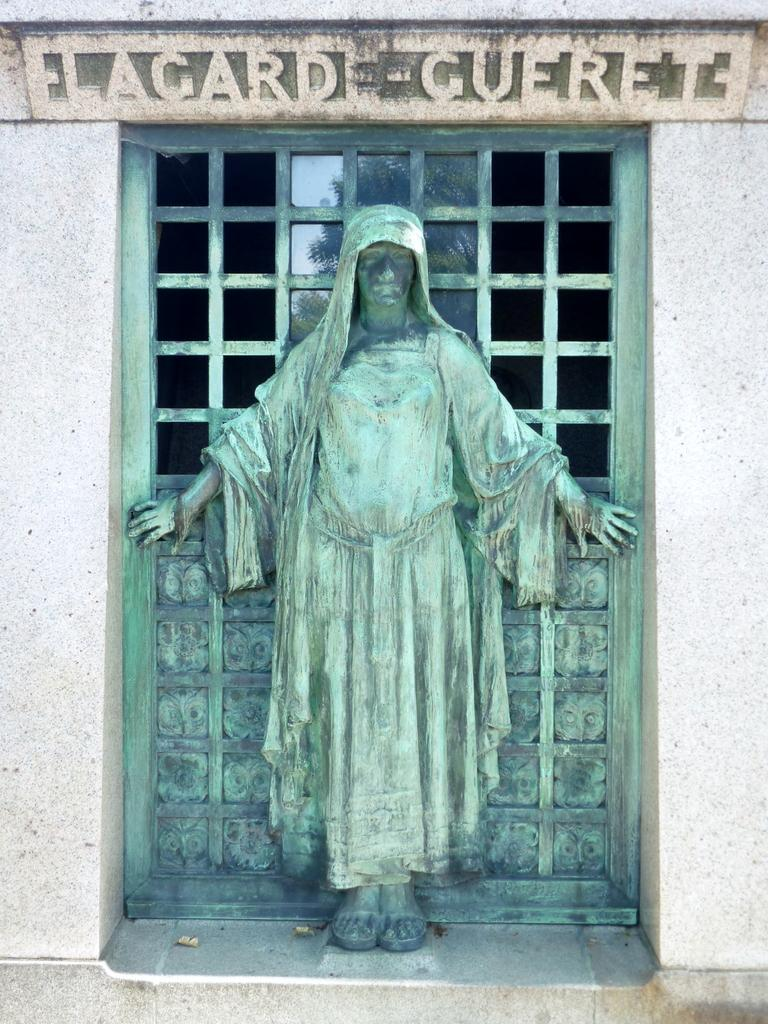What is the main subject of the image? There is a statue of a person in the image. Where is the statue located? The statue is placed on a wall. What is the surface behind the statue made of? The surface behind the statue is made of metal. What type of metal surface is it? The metal surface appears to be a window. What can be seen at the top of the image? There is text visible at the top of the image. How many family members are depicted in the image? There are no family members depicted in the image; it features a statue of a person. What type of card is being held by the person in the image? There is no card being held by the person in the image; it is a statue. 